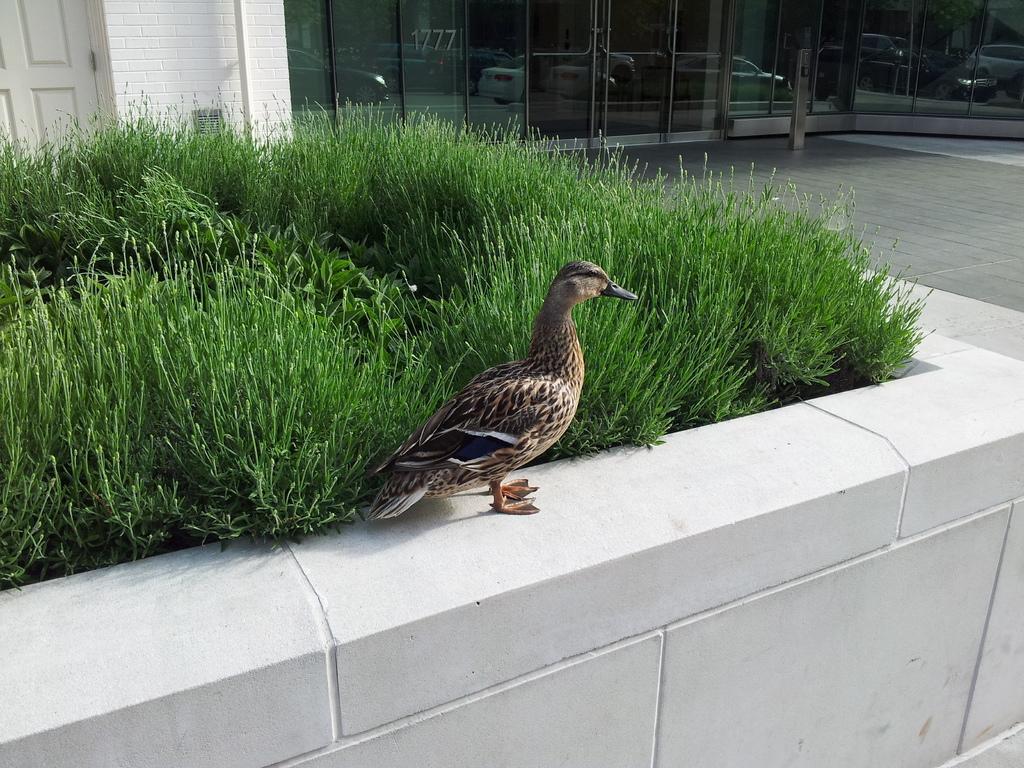Describe this image in one or two sentences. In this image I can see a bird standing on the rock. The bird is in brown and black color. To the side I can see the grass. In the background I can see the building and there are glass windows to it. 